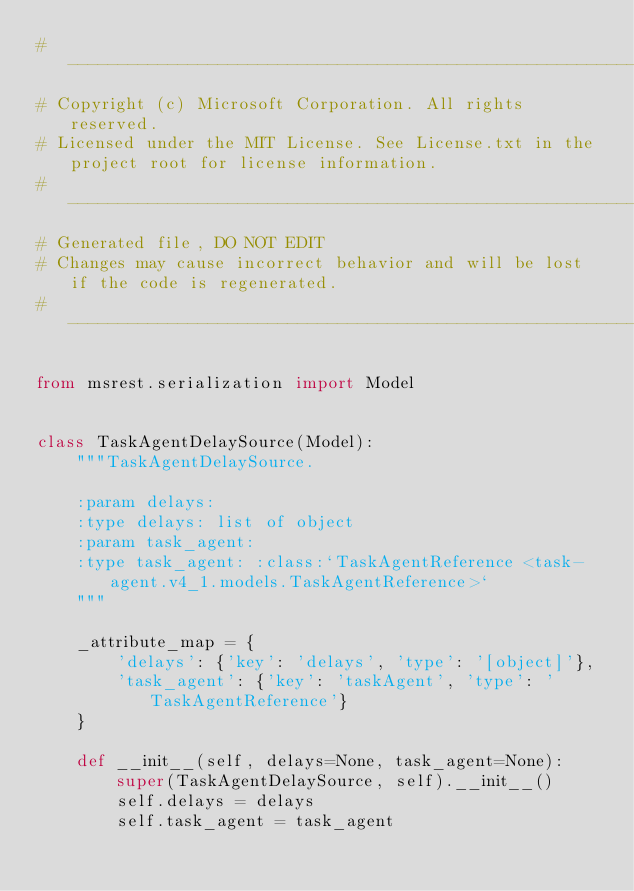Convert code to text. <code><loc_0><loc_0><loc_500><loc_500><_Python_># --------------------------------------------------------------------------------------------
# Copyright (c) Microsoft Corporation. All rights reserved.
# Licensed under the MIT License. See License.txt in the project root for license information.
# --------------------------------------------------------------------------------------------
# Generated file, DO NOT EDIT
# Changes may cause incorrect behavior and will be lost if the code is regenerated.
# --------------------------------------------------------------------------------------------

from msrest.serialization import Model


class TaskAgentDelaySource(Model):
    """TaskAgentDelaySource.

    :param delays:
    :type delays: list of object
    :param task_agent:
    :type task_agent: :class:`TaskAgentReference <task-agent.v4_1.models.TaskAgentReference>`
    """

    _attribute_map = {
        'delays': {'key': 'delays', 'type': '[object]'},
        'task_agent': {'key': 'taskAgent', 'type': 'TaskAgentReference'}
    }

    def __init__(self, delays=None, task_agent=None):
        super(TaskAgentDelaySource, self).__init__()
        self.delays = delays
        self.task_agent = task_agent
</code> 